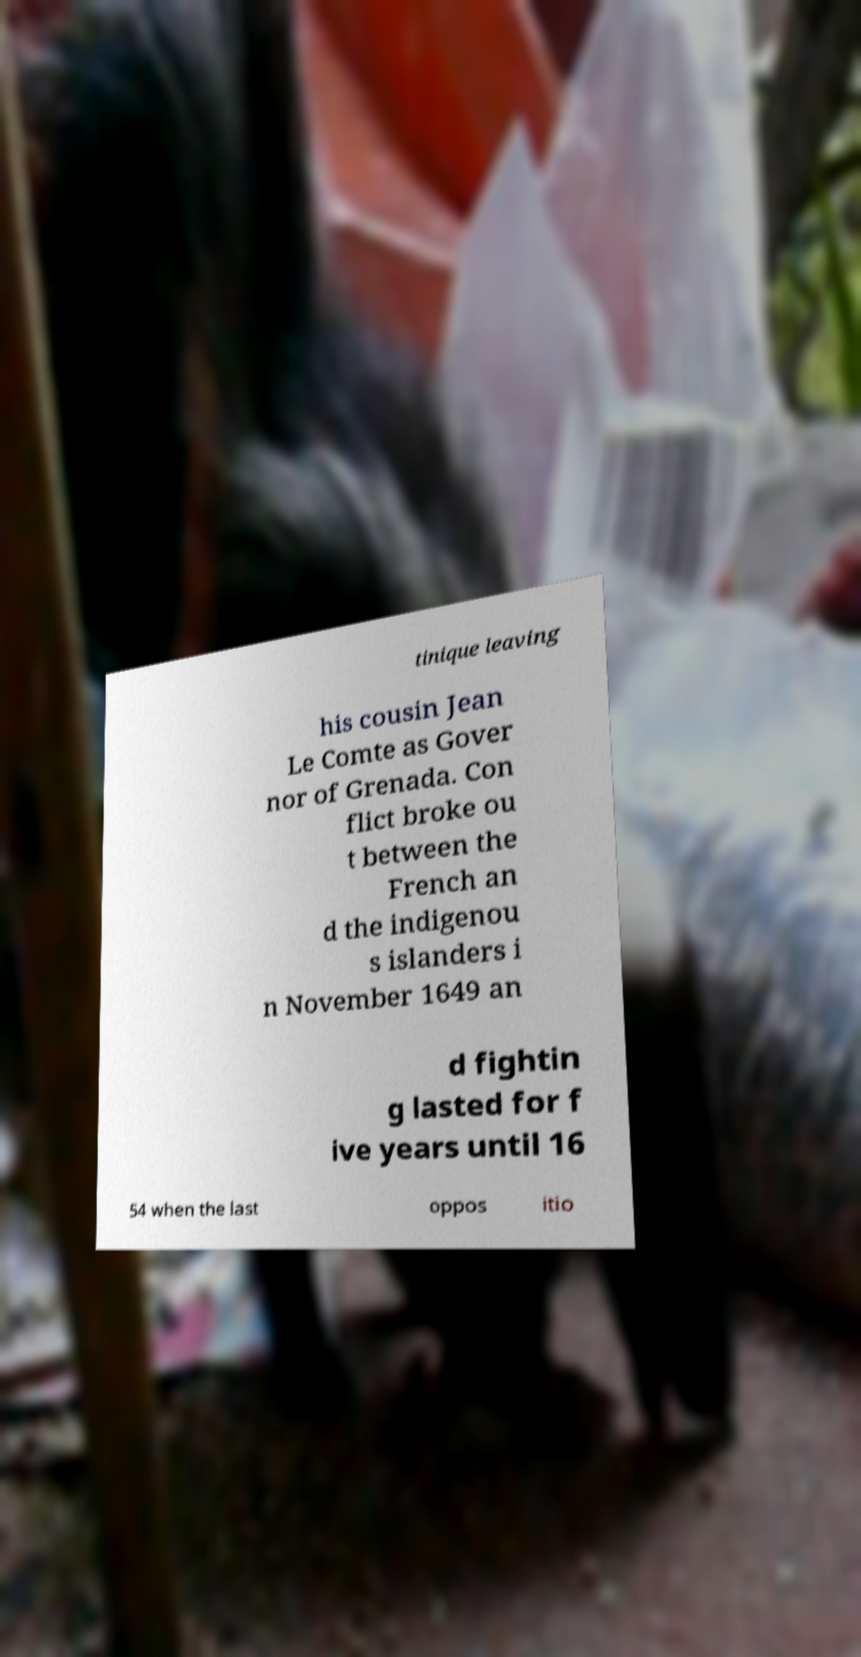Please identify and transcribe the text found in this image. tinique leaving his cousin Jean Le Comte as Gover nor of Grenada. Con flict broke ou t between the French an d the indigenou s islanders i n November 1649 an d fightin g lasted for f ive years until 16 54 when the last oppos itio 